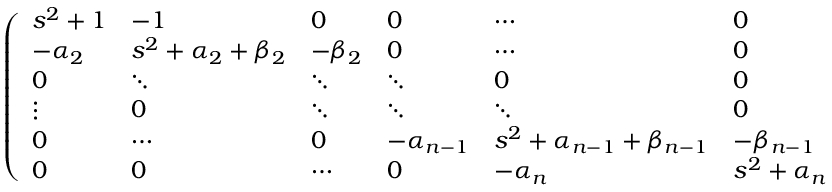Convert formula to latex. <formula><loc_0><loc_0><loc_500><loc_500>\begin{array} { r } { \left ( \begin{array} { l l l l l l } { s ^ { 2 } + 1 } & { - 1 } & { 0 } & { 0 } & { \cdots } & { 0 } \\ { - \alpha _ { 2 } } & { s ^ { 2 } + \alpha _ { 2 } + \beta _ { 2 } } & { - \beta _ { 2 } } & { 0 } & { \cdots } & { 0 } \\ { 0 } & { \ddots } & { \ddots } & { \ddots } & { 0 } & { 0 } \\ { \vdots } & { 0 } & { \ddots } & { \ddots } & { \ddots } & { 0 } \\ { 0 } & { \cdots } & { 0 } & { - \alpha _ { n - 1 } } & { s ^ { 2 } + \alpha _ { n - 1 } + \beta _ { n - 1 } } & { - \beta _ { n - 1 } } \\ { 0 } & { 0 } & { \cdots } & { 0 } & { - \alpha _ { n } } & { s ^ { 2 } + \alpha _ { n } } \end{array} \right ) \quad \left ( \begin{array} { l } { \hat { y } _ { 1 } ( s ) } \\ { \hat { y } _ { 2 } ( s ) } \\ { \hat { y } _ { 3 } ( s ) } \\ { \vdots } \\ { \hat { y } _ { n - 1 } ( s ) } \\ { \hat { y } _ { n } ( s ) } \end{array} \right ) = \left ( \begin{array} { l } { \frac { - 1 } { s } } \\ { 0 } \\ { 0 } \\ { \vdots } \\ { 0 } \\ { 0 } \end{array} \right ) } \end{array}</formula> 